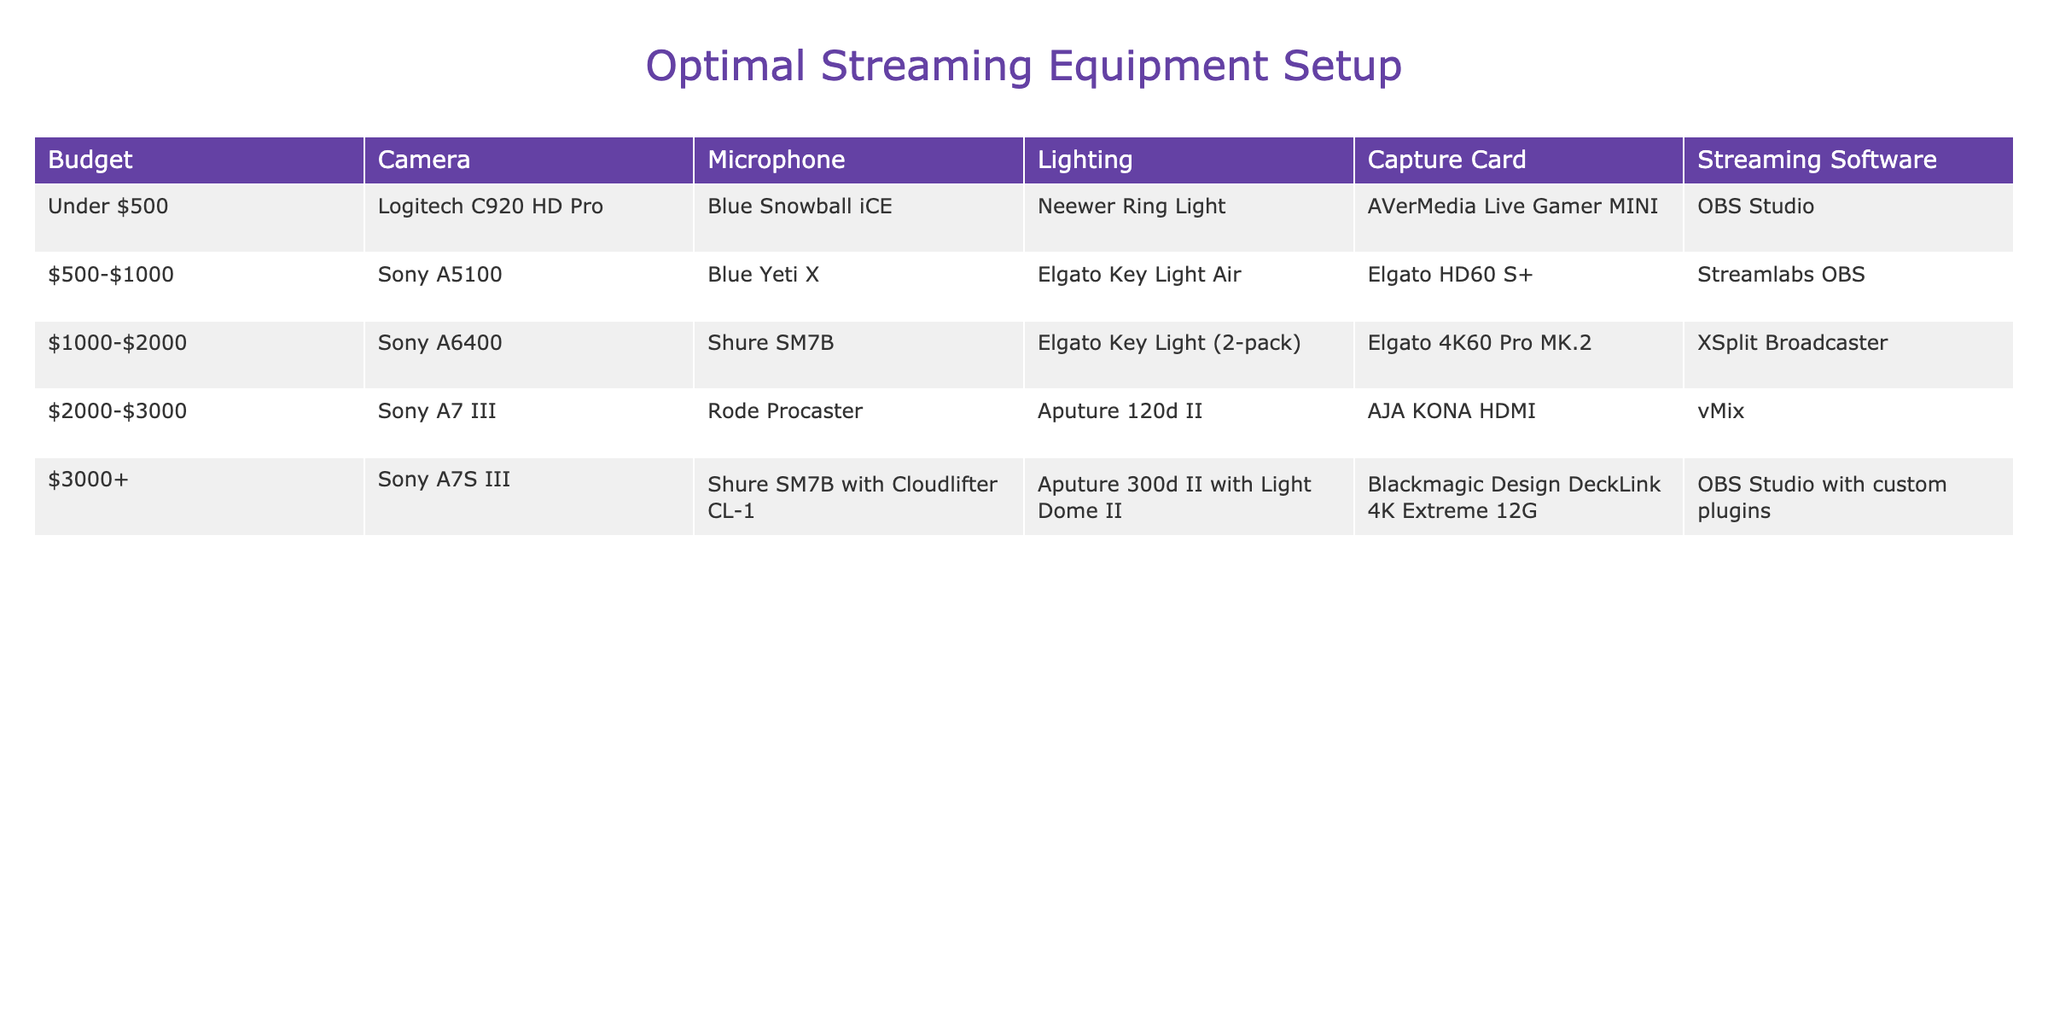What camera is recommended for a budget under $500? The table indicates that for a budget under $500, the recommended camera is the Logitech C920 HD Pro. This information can be directly found in the first row of the table.
Answer: Logitech C920 HD Pro Which budget range has the Sony A6400 as the camera option? According to the table, the Sony A6400 appears in the $1000-$2000 budget range, as seen in the third row.
Answer: $1000-$2000 Is a capture card included in the setup for budgets over $2000? Yes, the table shows that all setups in the budgets over $2000 include a capture card, specifically listed in the $2000-$3000 and $3000+ ranges.
Answer: Yes What is the difference in price range between the Sony A5100 and the Sony A7 III? The Sony A5100 is in the $500-$1000 range, while the Sony A7 III is in the $2000-$3000 range. The difference between the upper limit of the first range ($1000) and the lower limit of the second range ($2000) is $1000.
Answer: $1000 What streaming software is used for a budget of $3000 or more? For the budget of $3000 or more, the table indicates that the streaming software used is OBS Studio with custom plugins, which is listed in the last row.
Answer: OBS Studio with custom plugins What equipment would you choose if you have a budget of $1500? In the budget of $1000 to $2000, as the budget of $1500 falls within this range, you would select the Sony A6400 camera, Shure SM7B microphone, Elgato Key Light (2-pack) for lighting, Elgato 4K60 Pro MK.2 for a capture card, and XSplit Broadcaster as the streaming software. This involves looking at the third row of the table.
Answer: Sony A6400, Shure SM7B, Elgato Key Light (2-pack), Elgato 4K60 Pro MK.2, XSplit Broadcaster How many types of microphones are listed for budgets under $2000? For budgets under $2000, we consider both the $500-$1000 range and the $1000-$2000 range, which have the Blue Yeti X and Shure SM7B microphones, respectively. This gives us two distinct types of microphones.
Answer: 2 Is the Rode Procaster available in any budget category under $2000? No, the Rode Procaster is listed in the $2000-$3000 budget range according to the table, and thus is not available in any budget category under $2000.
Answer: No Which lighting setup offers the highest quality for the highest budget? The Aputure 300d II with Light Dome II is listed for the budget over $3000, which is the highest quality lighting in the table. This is determined by reviewing the last row where this equipment is listed.
Answer: Aputure 300d II with Light Dome II 